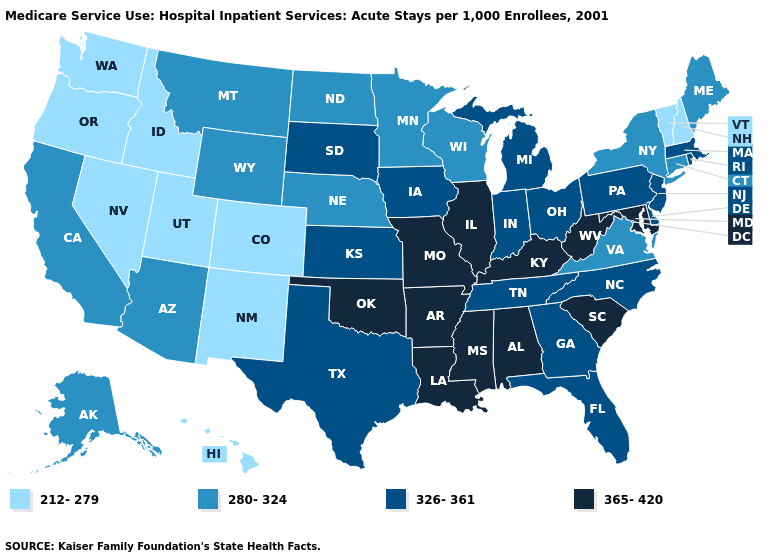What is the value of Kansas?
Short answer required. 326-361. What is the value of West Virginia?
Answer briefly. 365-420. What is the highest value in the Northeast ?
Write a very short answer. 326-361. Does Oklahoma have the highest value in the South?
Write a very short answer. Yes. Name the states that have a value in the range 326-361?
Answer briefly. Delaware, Florida, Georgia, Indiana, Iowa, Kansas, Massachusetts, Michigan, New Jersey, North Carolina, Ohio, Pennsylvania, Rhode Island, South Dakota, Tennessee, Texas. Among the states that border Ohio , which have the lowest value?
Concise answer only. Indiana, Michigan, Pennsylvania. Does New Mexico have a lower value than Nebraska?
Short answer required. Yes. Does Ohio have the lowest value in the MidWest?
Be succinct. No. Name the states that have a value in the range 280-324?
Keep it brief. Alaska, Arizona, California, Connecticut, Maine, Minnesota, Montana, Nebraska, New York, North Dakota, Virginia, Wisconsin, Wyoming. Does the map have missing data?
Give a very brief answer. No. What is the highest value in states that border Ohio?
Give a very brief answer. 365-420. What is the value of Tennessee?
Keep it brief. 326-361. What is the value of South Dakota?
Be succinct. 326-361. What is the value of South Dakota?
Short answer required. 326-361. 